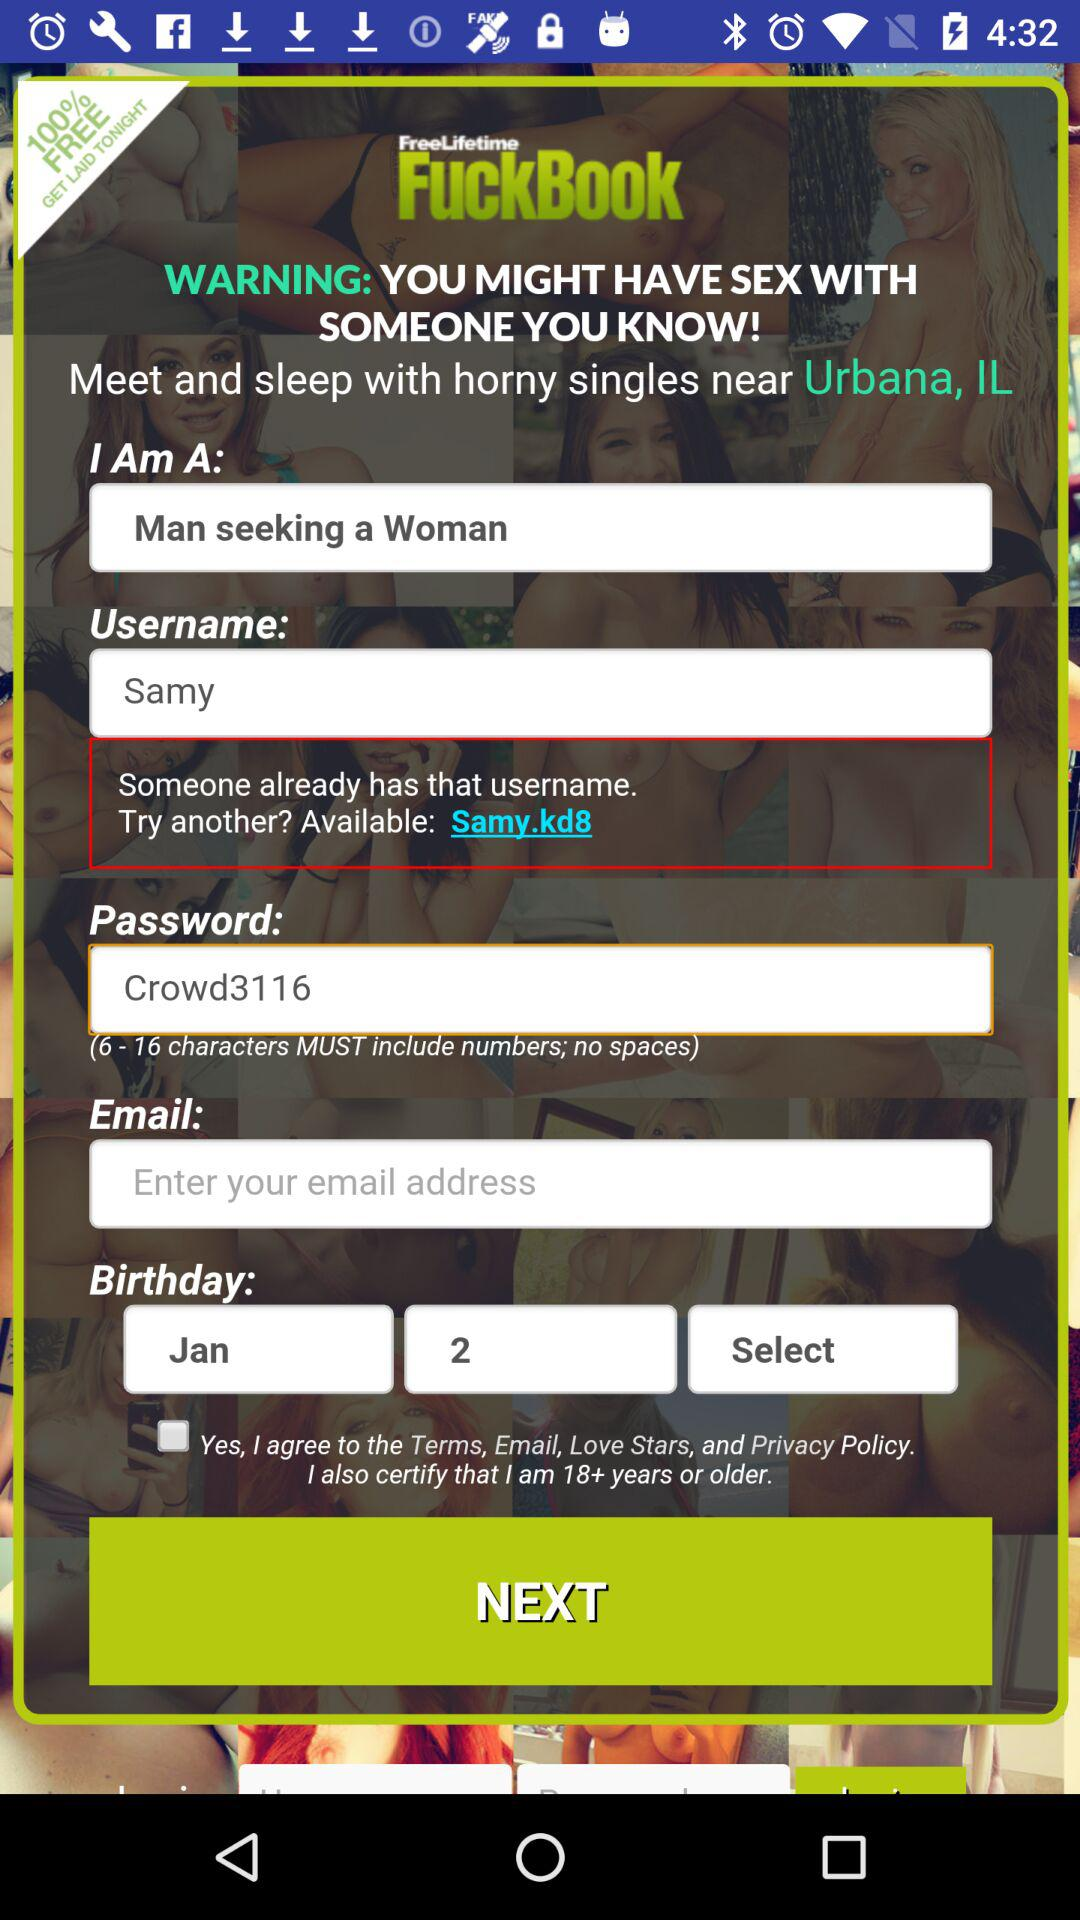What is the password? The password is Crowd3116. 